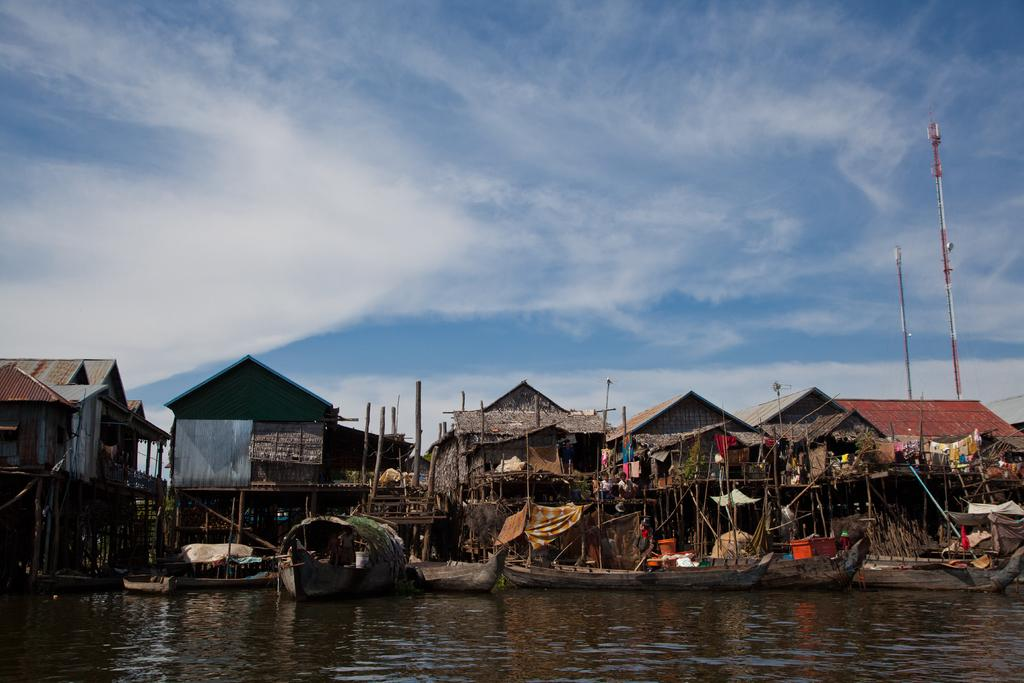What type of structures can be seen in the image? There are houses in the image. What is on the water in the image? There are boats on the water in the image. What can be found on the right side of the image? There are two poles on the right side of the image. What is visible in the background of the image? There is a sky visible in the background of the image. What can be observed in the sky? There are clouds in the sky. What committee is responsible for the maintenance of the boats in the image? There is no information about a committee in the image, and the image does not show any boats being maintained. --- Facts: 1. There is a person sitting on a chair in the image. 2. The person is holding a book. 3. There is a table next to the chair. 4. There is a lamp on the table. 5. The background of the image is a room. Absurd Topics: elephant, ocean, dance Conversation: What is the person in the image doing? The person is sitting on a chair in the image. What is the person holding in the image? The person is holding a book. What is located next to the chair in the image? There is a table next to the chair. What is on the table in the image? There is a lamp on the table. What type of setting is depicted in the image? The background of the image is a room. Reasoning: Let's think step by step in order to produce the conversation. We start by identifying the main subject in the image, which is the person sitting on a chair. Then, we expand the conversation to include other items that are also visible, such as the book, table, lamp, and the room setting. Each question is designed to elicit a specific detail about the image that is known from the provided facts. Absurd Question/Answer: Can you see an elephant swimming in the ocean in the image? No, there is no elephant or ocean present in the image. 